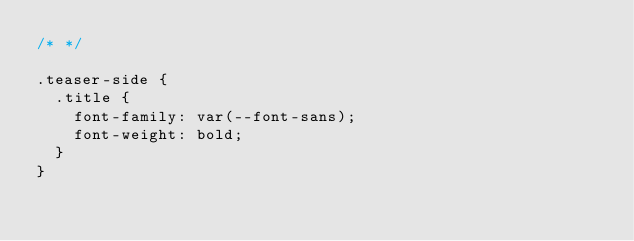<code> <loc_0><loc_0><loc_500><loc_500><_CSS_>/* */

.teaser-side {
  .title {
    font-family: var(--font-sans);
    font-weight: bold;
  }
}
</code> 